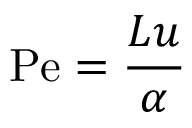Convert formula to latex. <formula><loc_0><loc_0><loc_500><loc_500>P e = { \frac { L u } { \alpha } }</formula> 